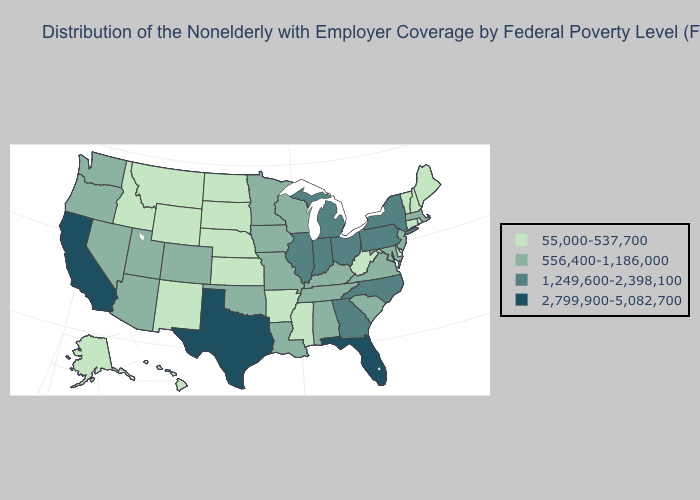Name the states that have a value in the range 556,400-1,186,000?
Quick response, please. Alabama, Arizona, Colorado, Iowa, Kentucky, Louisiana, Maryland, Massachusetts, Minnesota, Missouri, Nevada, New Jersey, Oklahoma, Oregon, South Carolina, Tennessee, Utah, Virginia, Washington, Wisconsin. Which states have the highest value in the USA?
Give a very brief answer. California, Florida, Texas. Name the states that have a value in the range 2,799,900-5,082,700?
Quick response, please. California, Florida, Texas. Does New Jersey have the lowest value in the Northeast?
Write a very short answer. No. Does Michigan have the highest value in the MidWest?
Quick response, please. Yes. Among the states that border Louisiana , which have the highest value?
Give a very brief answer. Texas. What is the value of California?
Write a very short answer. 2,799,900-5,082,700. What is the highest value in the USA?
Keep it brief. 2,799,900-5,082,700. What is the value of New Hampshire?
Answer briefly. 55,000-537,700. Name the states that have a value in the range 1,249,600-2,398,100?
Quick response, please. Georgia, Illinois, Indiana, Michigan, New York, North Carolina, Ohio, Pennsylvania. Which states have the lowest value in the USA?
Answer briefly. Alaska, Arkansas, Connecticut, Delaware, Hawaii, Idaho, Kansas, Maine, Mississippi, Montana, Nebraska, New Hampshire, New Mexico, North Dakota, Rhode Island, South Dakota, Vermont, West Virginia, Wyoming. What is the highest value in the West ?
Give a very brief answer. 2,799,900-5,082,700. Does South Dakota have the lowest value in the MidWest?
Keep it brief. Yes. Name the states that have a value in the range 55,000-537,700?
Quick response, please. Alaska, Arkansas, Connecticut, Delaware, Hawaii, Idaho, Kansas, Maine, Mississippi, Montana, Nebraska, New Hampshire, New Mexico, North Dakota, Rhode Island, South Dakota, Vermont, West Virginia, Wyoming. What is the lowest value in states that border South Carolina?
Answer briefly. 1,249,600-2,398,100. 